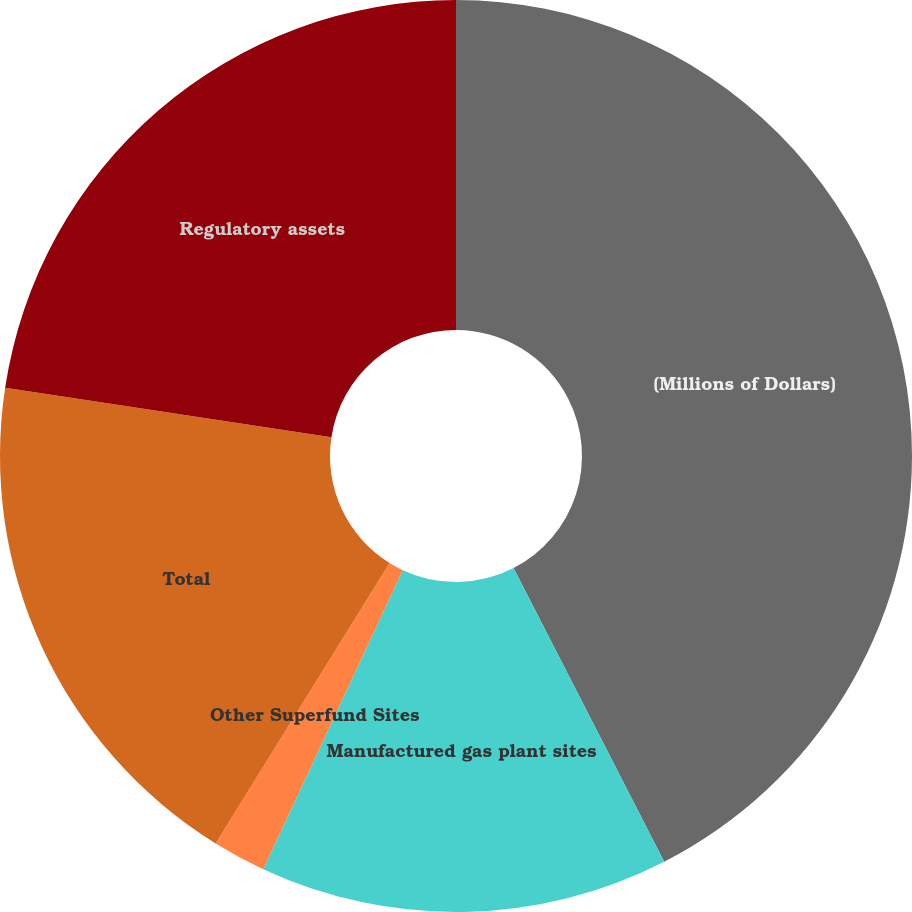Convert chart to OTSL. <chart><loc_0><loc_0><loc_500><loc_500><pie_chart><fcel>(Millions of Dollars)<fcel>Manufactured gas plant sites<fcel>Other Superfund Sites<fcel>Total<fcel>Regulatory assets<nl><fcel>42.45%<fcel>14.49%<fcel>1.89%<fcel>18.55%<fcel>22.61%<nl></chart> 